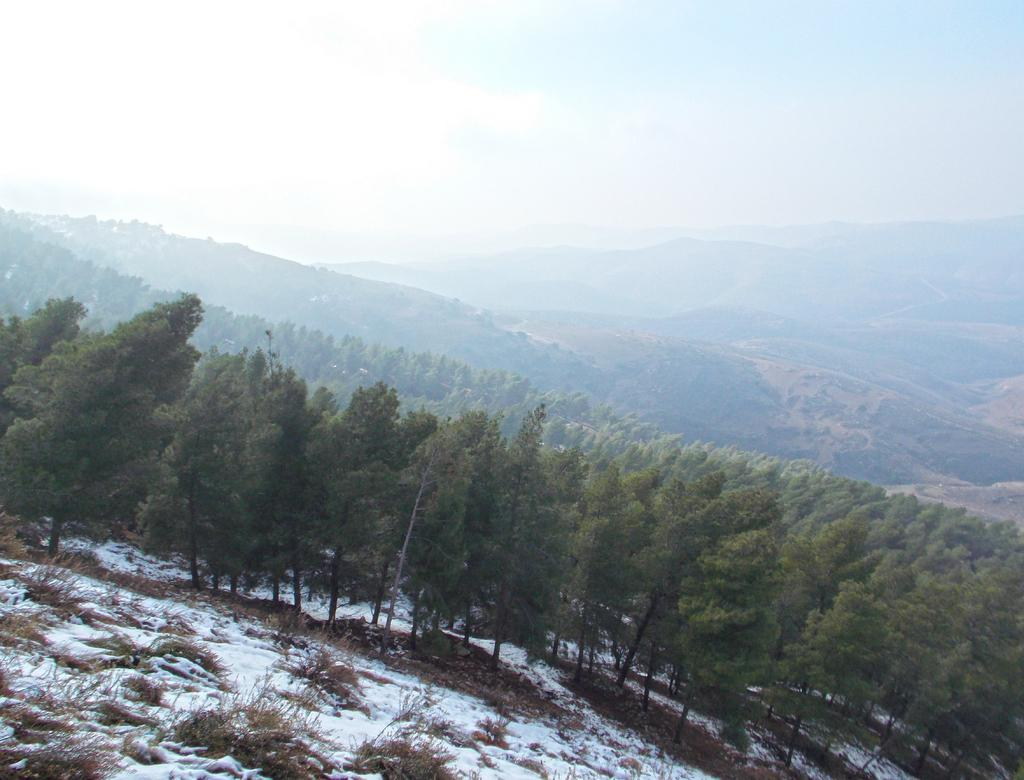What type of natural landscape is depicted in the image? The image features mountains, trees, plants, bushes, and grass, indicating a mountainous landscape. What is the condition of the mountains in the image? The surface of the mountains has snow in the image. What can be seen in the sky at the top of the image? The sky is visible at the top of the image. What type of food is being offered to the zephyr in the image? There is no zephyr or food present in the image. What type of offer can be seen being made to the plants in the image? There is no offer being made to the plants in the image; they are simply depicted as part of the landscape. 